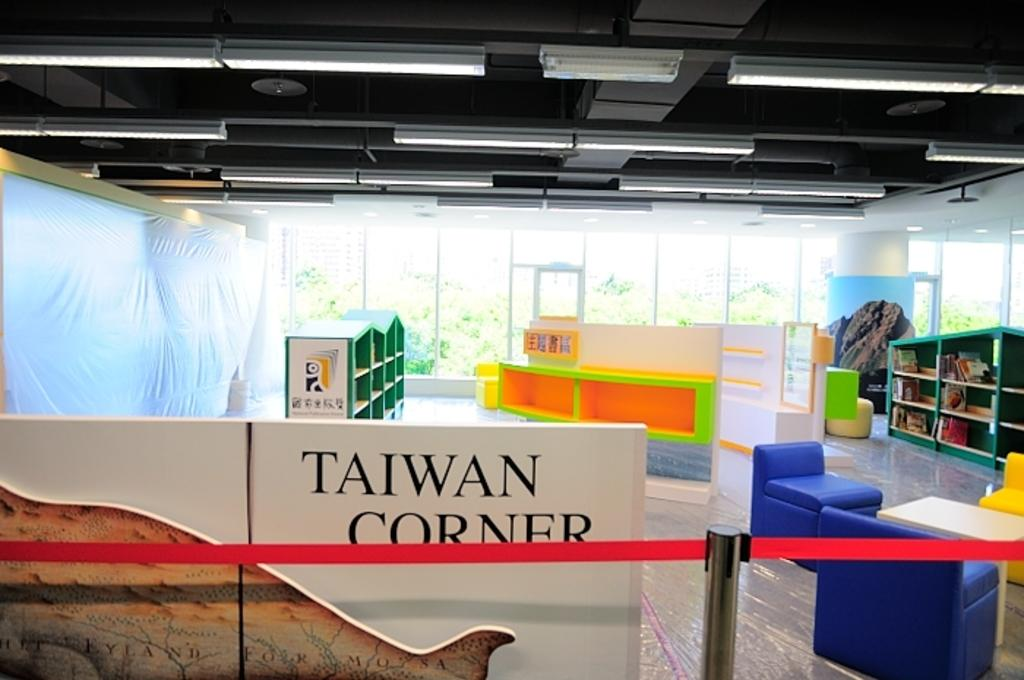<image>
Provide a brief description of the given image. A children's book store is empty and has a sign that says Taiwan Corner. 